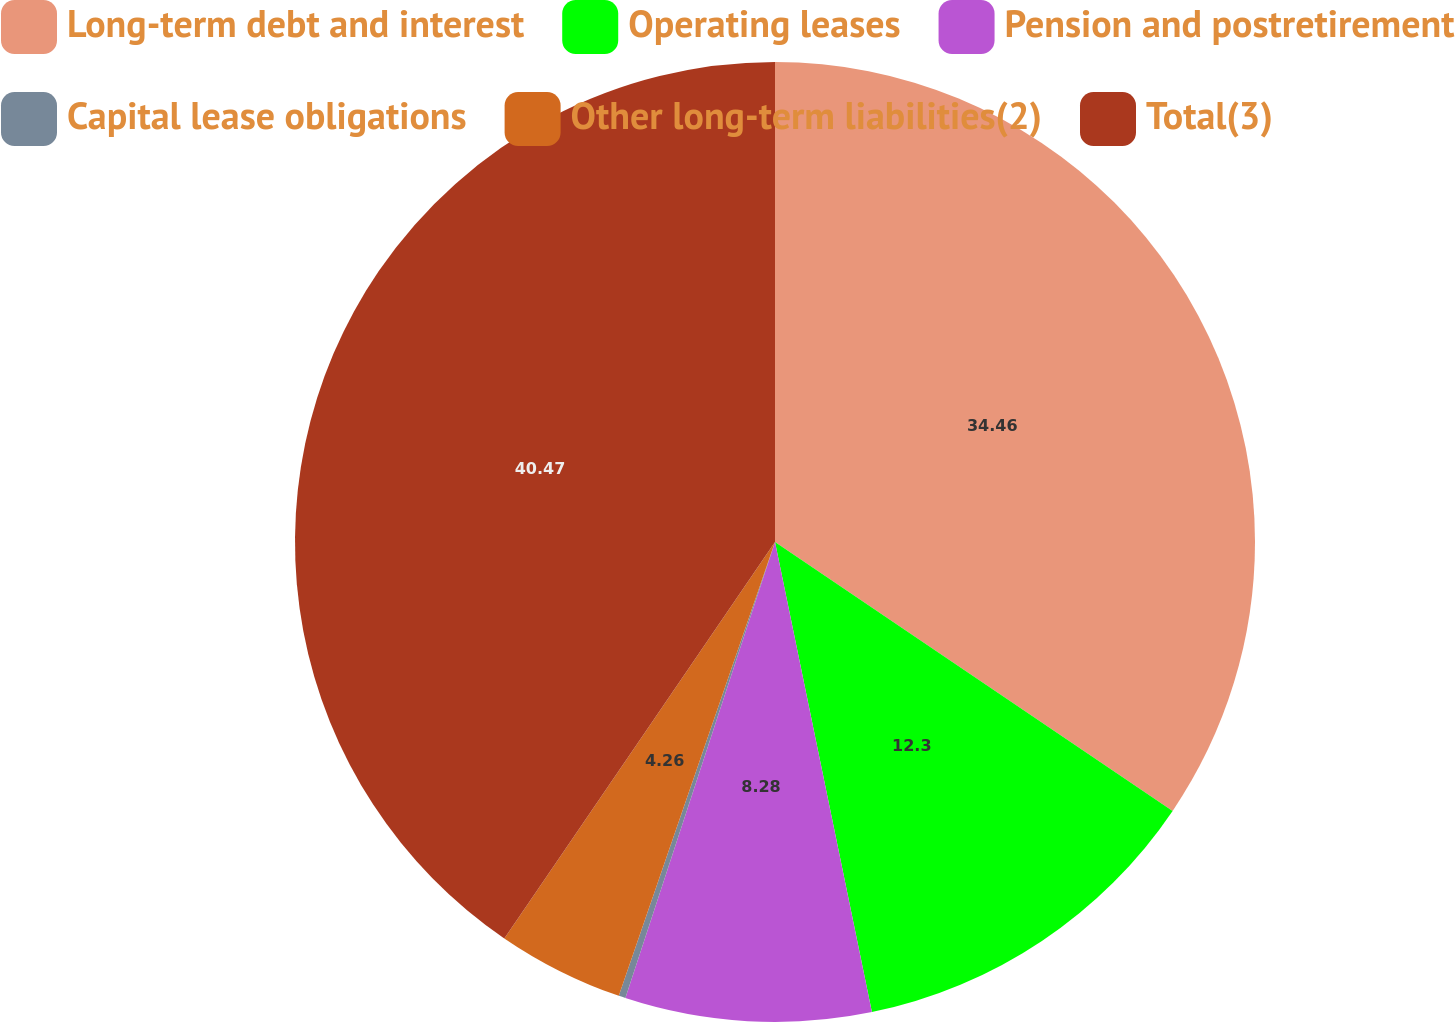<chart> <loc_0><loc_0><loc_500><loc_500><pie_chart><fcel>Long-term debt and interest<fcel>Operating leases<fcel>Pension and postretirement<fcel>Capital lease obligations<fcel>Other long-term liabilities(2)<fcel>Total(3)<nl><fcel>34.46%<fcel>12.3%<fcel>8.28%<fcel>0.23%<fcel>4.26%<fcel>40.46%<nl></chart> 